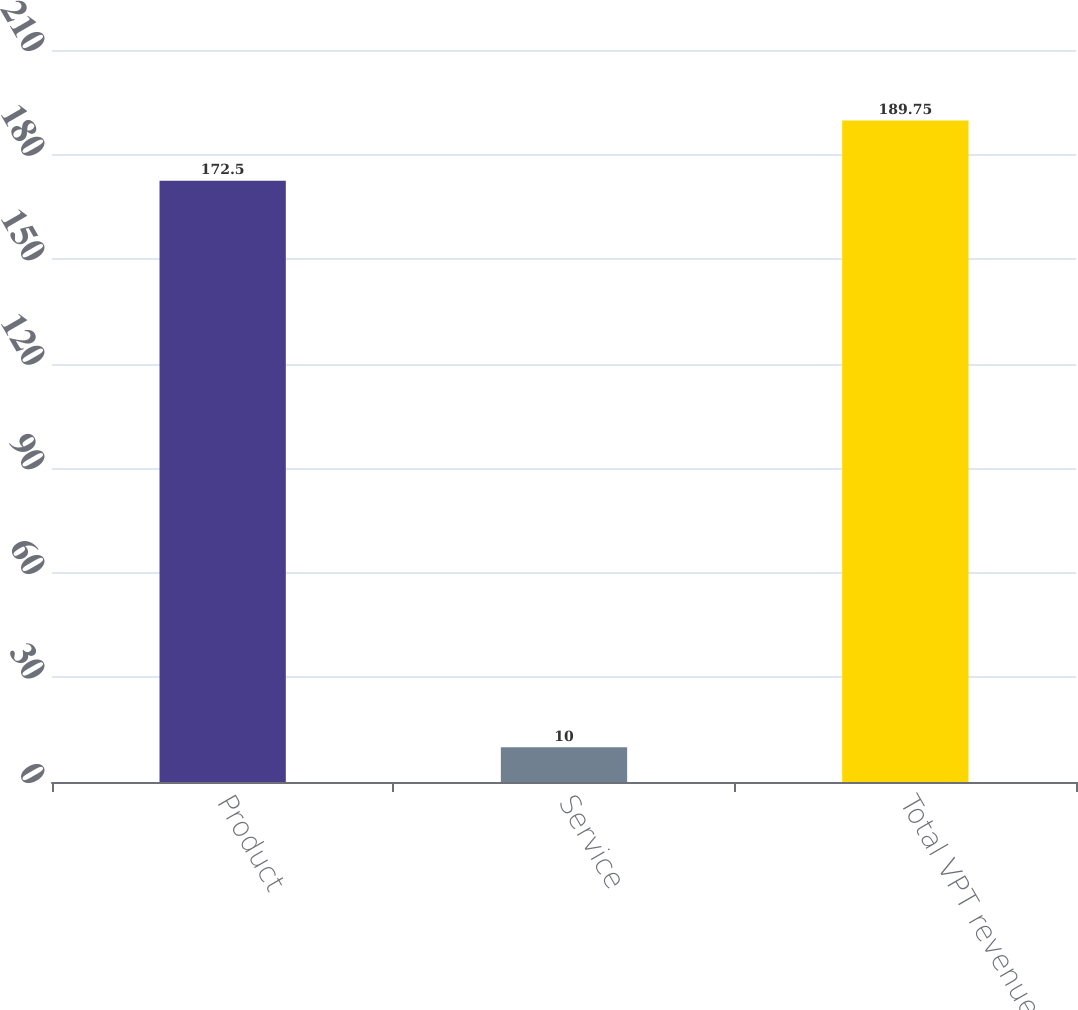Convert chart. <chart><loc_0><loc_0><loc_500><loc_500><bar_chart><fcel>Product<fcel>Service<fcel>Total VPT revenues<nl><fcel>172.5<fcel>10<fcel>189.75<nl></chart> 